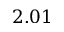<formula> <loc_0><loc_0><loc_500><loc_500>2 . 0 1</formula> 